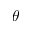<formula> <loc_0><loc_0><loc_500><loc_500>\theta</formula> 